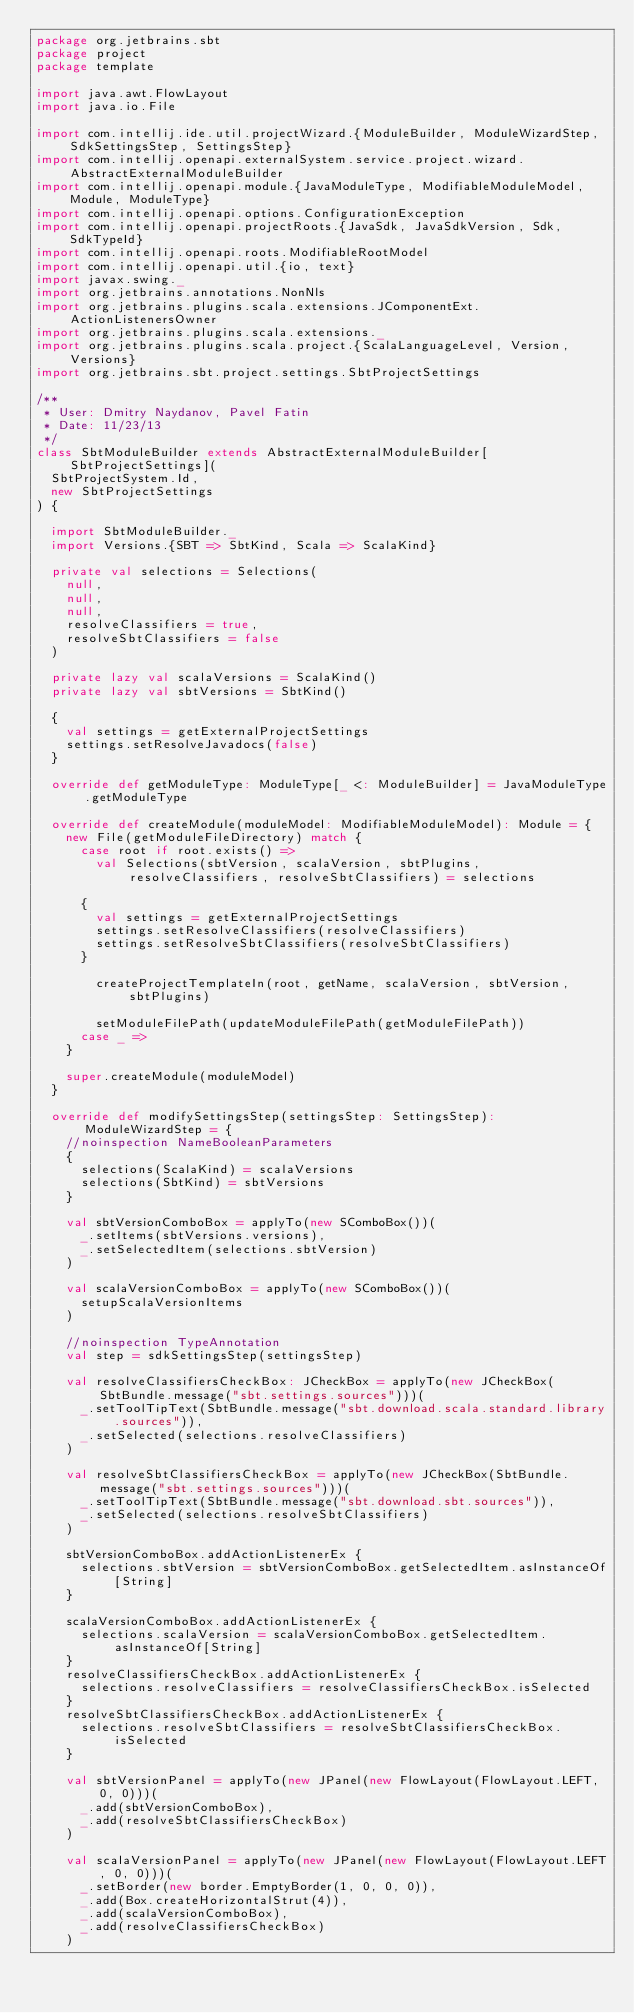<code> <loc_0><loc_0><loc_500><loc_500><_Scala_>package org.jetbrains.sbt
package project
package template

import java.awt.FlowLayout
import java.io.File

import com.intellij.ide.util.projectWizard.{ModuleBuilder, ModuleWizardStep, SdkSettingsStep, SettingsStep}
import com.intellij.openapi.externalSystem.service.project.wizard.AbstractExternalModuleBuilder
import com.intellij.openapi.module.{JavaModuleType, ModifiableModuleModel, Module, ModuleType}
import com.intellij.openapi.options.ConfigurationException
import com.intellij.openapi.projectRoots.{JavaSdk, JavaSdkVersion, Sdk, SdkTypeId}
import com.intellij.openapi.roots.ModifiableRootModel
import com.intellij.openapi.util.{io, text}
import javax.swing._
import org.jetbrains.annotations.NonNls
import org.jetbrains.plugins.scala.extensions.JComponentExt.ActionListenersOwner
import org.jetbrains.plugins.scala.extensions._
import org.jetbrains.plugins.scala.project.{ScalaLanguageLevel, Version, Versions}
import org.jetbrains.sbt.project.settings.SbtProjectSettings

/**
 * User: Dmitry Naydanov, Pavel Fatin
 * Date: 11/23/13
 */
class SbtModuleBuilder extends AbstractExternalModuleBuilder[SbtProjectSettings](
  SbtProjectSystem.Id,
  new SbtProjectSettings
) {

  import SbtModuleBuilder._
  import Versions.{SBT => SbtKind, Scala => ScalaKind}

  private val selections = Selections(
    null,
    null,
    null,
    resolveClassifiers = true,
    resolveSbtClassifiers = false
  )

  private lazy val scalaVersions = ScalaKind()
  private lazy val sbtVersions = SbtKind()

  {
    val settings = getExternalProjectSettings
    settings.setResolveJavadocs(false)
  }

  override def getModuleType: ModuleType[_ <: ModuleBuilder] = JavaModuleType.getModuleType

  override def createModule(moduleModel: ModifiableModuleModel): Module = {
    new File(getModuleFileDirectory) match {
      case root if root.exists() =>
        val Selections(sbtVersion, scalaVersion, sbtPlugins, resolveClassifiers, resolveSbtClassifiers) = selections

      {
        val settings = getExternalProjectSettings
        settings.setResolveClassifiers(resolveClassifiers)
        settings.setResolveSbtClassifiers(resolveSbtClassifiers)
      }

        createProjectTemplateIn(root, getName, scalaVersion, sbtVersion, sbtPlugins)

        setModuleFilePath(updateModuleFilePath(getModuleFilePath))
      case _ =>
    }

    super.createModule(moduleModel)
  }

  override def modifySettingsStep(settingsStep: SettingsStep): ModuleWizardStep = {
    //noinspection NameBooleanParameters
    {
      selections(ScalaKind) = scalaVersions
      selections(SbtKind) = sbtVersions
    }

    val sbtVersionComboBox = applyTo(new SComboBox())(
      _.setItems(sbtVersions.versions),
      _.setSelectedItem(selections.sbtVersion)
    )

    val scalaVersionComboBox = applyTo(new SComboBox())(
      setupScalaVersionItems
    )

    //noinspection TypeAnnotation
    val step = sdkSettingsStep(settingsStep)

    val resolveClassifiersCheckBox: JCheckBox = applyTo(new JCheckBox(SbtBundle.message("sbt.settings.sources")))(
      _.setToolTipText(SbtBundle.message("sbt.download.scala.standard.library.sources")),
      _.setSelected(selections.resolveClassifiers)
    )

    val resolveSbtClassifiersCheckBox = applyTo(new JCheckBox(SbtBundle.message("sbt.settings.sources")))(
      _.setToolTipText(SbtBundle.message("sbt.download.sbt.sources")),
      _.setSelected(selections.resolveSbtClassifiers)
    )

    sbtVersionComboBox.addActionListenerEx {
      selections.sbtVersion = sbtVersionComboBox.getSelectedItem.asInstanceOf[String]
    }

    scalaVersionComboBox.addActionListenerEx {
      selections.scalaVersion = scalaVersionComboBox.getSelectedItem.asInstanceOf[String]
    }
    resolveClassifiersCheckBox.addActionListenerEx {
      selections.resolveClassifiers = resolveClassifiersCheckBox.isSelected
    }
    resolveSbtClassifiersCheckBox.addActionListenerEx {
      selections.resolveSbtClassifiers = resolveSbtClassifiersCheckBox.isSelected
    }

    val sbtVersionPanel = applyTo(new JPanel(new FlowLayout(FlowLayout.LEFT, 0, 0)))(
      _.add(sbtVersionComboBox),
      _.add(resolveSbtClassifiersCheckBox)
    )

    val scalaVersionPanel = applyTo(new JPanel(new FlowLayout(FlowLayout.LEFT, 0, 0)))(
      _.setBorder(new border.EmptyBorder(1, 0, 0, 0)),
      _.add(Box.createHorizontalStrut(4)),
      _.add(scalaVersionComboBox),
      _.add(resolveClassifiersCheckBox)
    )
</code> 